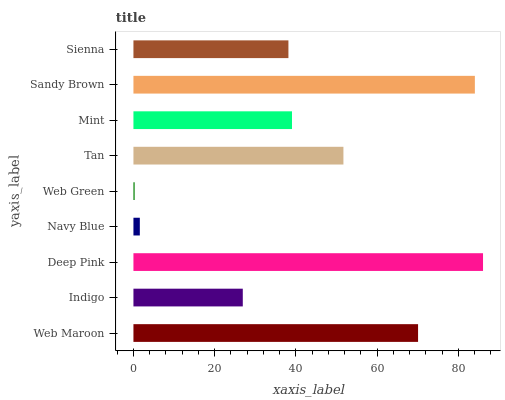Is Web Green the minimum?
Answer yes or no. Yes. Is Deep Pink the maximum?
Answer yes or no. Yes. Is Indigo the minimum?
Answer yes or no. No. Is Indigo the maximum?
Answer yes or no. No. Is Web Maroon greater than Indigo?
Answer yes or no. Yes. Is Indigo less than Web Maroon?
Answer yes or no. Yes. Is Indigo greater than Web Maroon?
Answer yes or no. No. Is Web Maroon less than Indigo?
Answer yes or no. No. Is Mint the high median?
Answer yes or no. Yes. Is Mint the low median?
Answer yes or no. Yes. Is Sienna the high median?
Answer yes or no. No. Is Tan the low median?
Answer yes or no. No. 